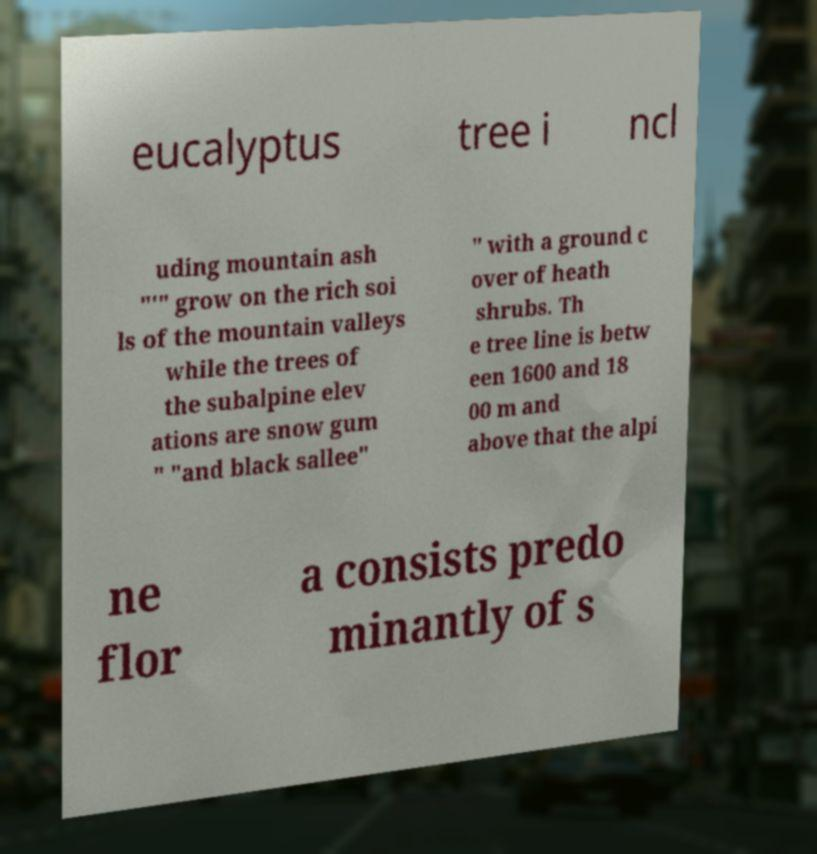Could you assist in decoding the text presented in this image and type it out clearly? eucalyptus tree i ncl uding mountain ash "'" grow on the rich soi ls of the mountain valleys while the trees of the subalpine elev ations are snow gum " "and black sallee" " with a ground c over of heath shrubs. Th e tree line is betw een 1600 and 18 00 m and above that the alpi ne flor a consists predo minantly of s 